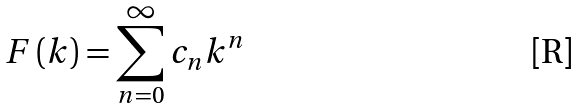<formula> <loc_0><loc_0><loc_500><loc_500>F \left ( k \right ) = \sum _ { n = 0 } ^ { \infty } c _ { n } k ^ { n }</formula> 